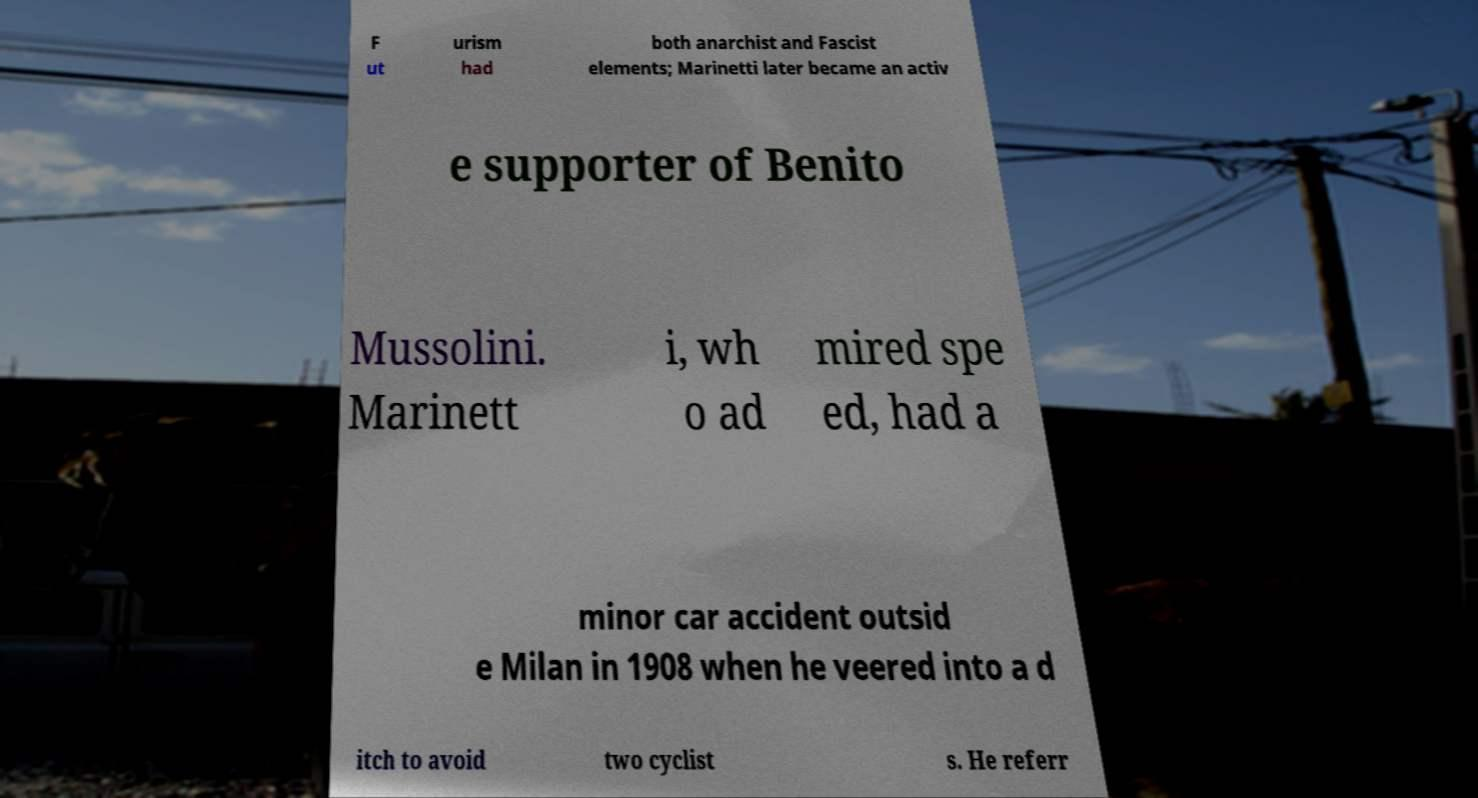For documentation purposes, I need the text within this image transcribed. Could you provide that? F ut urism had both anarchist and Fascist elements; Marinetti later became an activ e supporter of Benito Mussolini. Marinett i, wh o ad mired spe ed, had a minor car accident outsid e Milan in 1908 when he veered into a d itch to avoid two cyclist s. He referr 